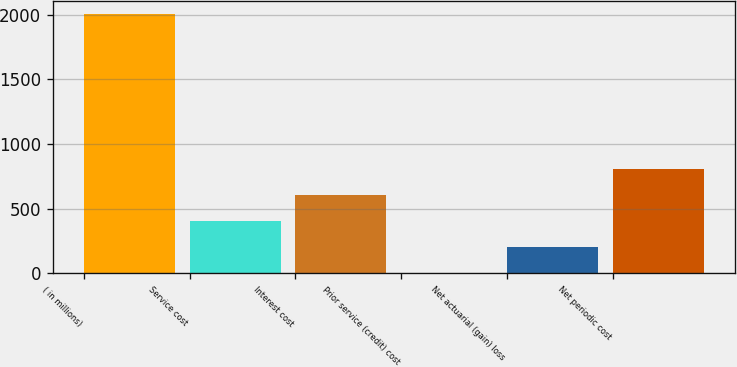<chart> <loc_0><loc_0><loc_500><loc_500><bar_chart><fcel>( in millions)<fcel>Service cost<fcel>Interest cost<fcel>Prior service (credit) cost<fcel>Net actuarial (gain) loss<fcel>Net periodic cost<nl><fcel>2007<fcel>402.2<fcel>602.8<fcel>1<fcel>201.6<fcel>803.4<nl></chart> 